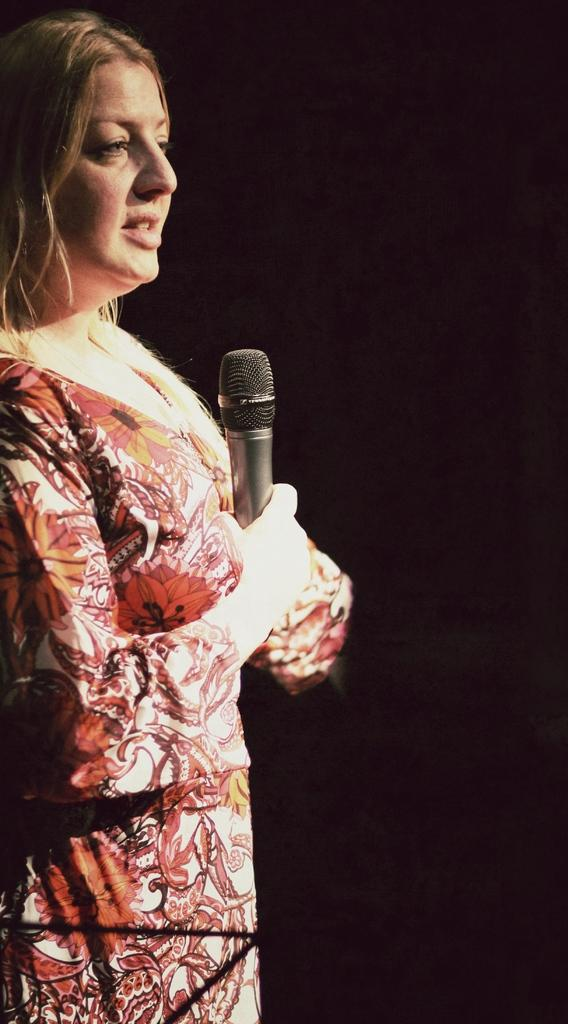Who is the main subject in the image? There is a woman in the image. Where is the woman positioned in the image? The woman is standing on the left side. What is the woman holding in her hand? The woman is holding a mic in her hand. Can you see any friends of the woman in the image? There is no information about friends in the image, so we cannot determine if any are present. Is the woman standing near the sea in the image? There is no information about the sea or any body of water in the image, so we cannot determine if she is near it. 